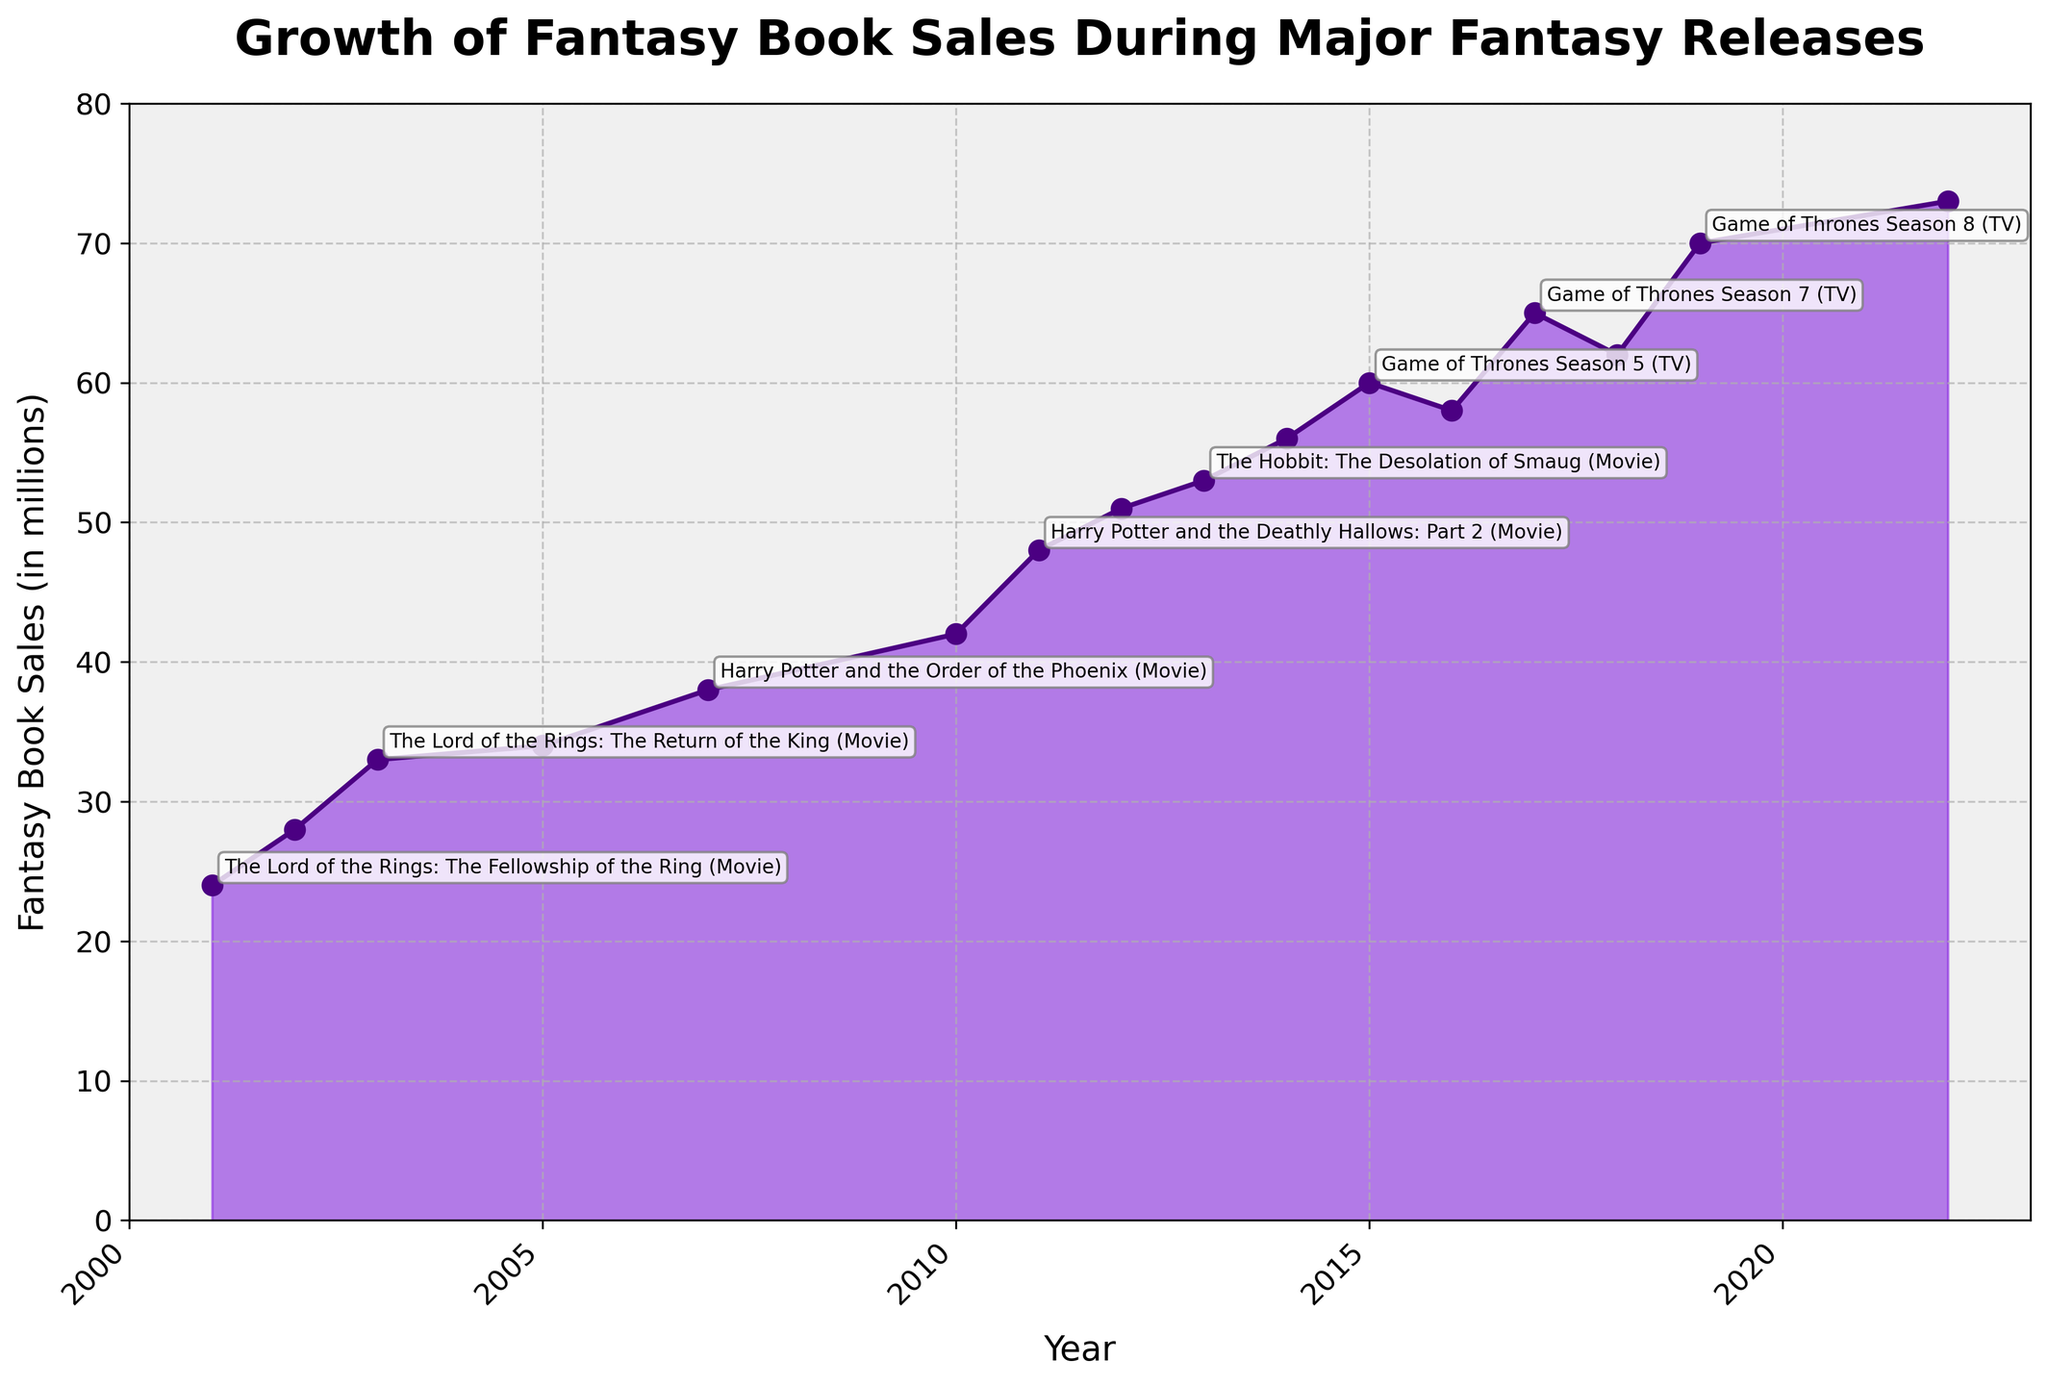What's the highest value of fantasy book sales shown in the chart? The highest point on the chart represents the maximum value. From the data provided, the highest fantasy book sales are in 2022.
Answer: 73 million What major event coincided with the highest fantasy book sales in 2022? According to the annotations on the chart, the highest sales in 2022 coincide with "The Lord of the Rings: The Rings of Power (TV)" release.
Answer: The Lord of the Rings: The Rings of Power (TV) What is the overall trend of fantasy book sales from 2001 to 2022? Observing the area chart, the general trend is an increase in fantasy book sales over the years, starting from 24 million in 2001 to 73 million in 2022.
Answer: Increasing trend Which movie or adaptation led to the first noticeable spike in fantasy book sales? The significant increase in sales occurs between 2001 and 2002. This spike corresponds with the release of "The Lord of the Rings: The Fellowship of the Ring (Movie)" in 2001.
Answer: The Lord of the Rings: The Fellowship of the Ring (Movie) By how much did fantasy book sales increase from 2001 to 2002? To find the increase, subtract the sales in 2001 from the sales in 2002: 28 million (2002) - 24 million (2001)
Answer: 4 million During which year did "Harry Potter and the Deathly Hallows: Part 2 (Movie)" release, and what was the fantasy book sales figure for that year? According to the annotations, "Harry Potter and the Deathly Hallows: Part 2 (Movie)" released in 2011, with the fantasy book sales reaching 48 million.
Answer: 2011, 48 million What was the difference in fantasy book sales between 2013 and 2014? Subtract the sales in 2013 from the sales in 2014: 56 million (2014) - 53 million (2013)
Answer: 3 million Which TV event marked the highest increase in year-over-year fantasy book sales? Comparing the TV events, "Game of Thrones Season 8 (TV)" in 2019 shows the highest increase from its previous point, with sales reaching 70 million.
Answer: Game of Thrones Season 8 (TV) What can be observed about the sales trend during the releases of "The Hobbit" movies from 2012 to 2014? The sales trend shows a consistent increase from 2012 to 2014, with each release of "The Hobbit" movies contributing to higher sales: 2012 - 51 million, 2013 - 53 million, 2014 - 56 million.
Answer: Consistent increase How does the fantasy book sales in 2016 compare to the previous year, and what event took place in 2016? Comparing 2016 to 2015, there is a slight decline in sales from 60 million to 58 million. The event in 2016 is "Fantastic Beasts and Where to Find Them (Movie)."
Answer: Decline, Fantastic Beasts and Where to Find Them (Movie) 